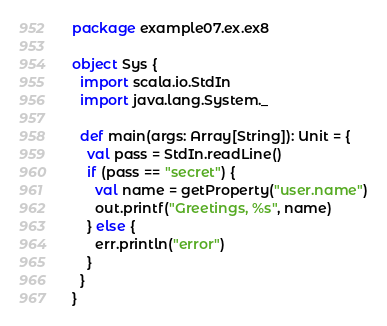<code> <loc_0><loc_0><loc_500><loc_500><_Scala_>package example07.ex.ex8

object Sys {
  import scala.io.StdIn
  import java.lang.System._

  def main(args: Array[String]): Unit = {
    val pass = StdIn.readLine()
    if (pass == "secret") {
      val name = getProperty("user.name")
      out.printf("Greetings, %s", name)
    } else {
      err.println("error")
    }
  }
}</code> 